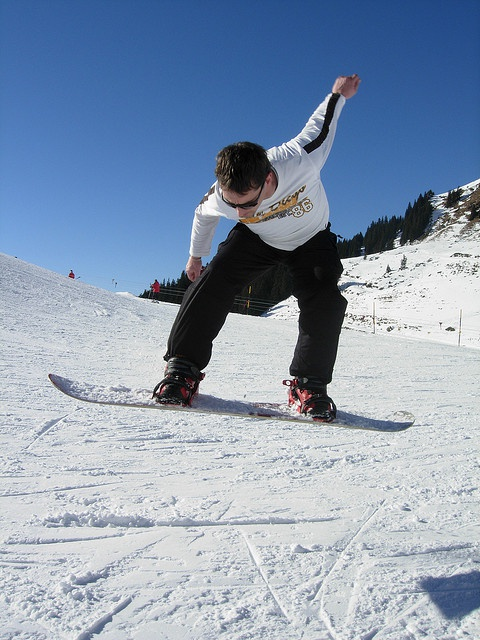Describe the objects in this image and their specific colors. I can see people in blue, black, darkgray, gray, and lightgray tones, snowboard in blue, gray, lightgray, and darkgray tones, people in blue, maroon, black, brown, and gray tones, and people in blue, maroon, brown, purple, and gray tones in this image. 